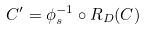Convert formula to latex. <formula><loc_0><loc_0><loc_500><loc_500>C ^ { \prime } = \phi _ { s } ^ { - 1 } \circ R _ { D } ( C )</formula> 